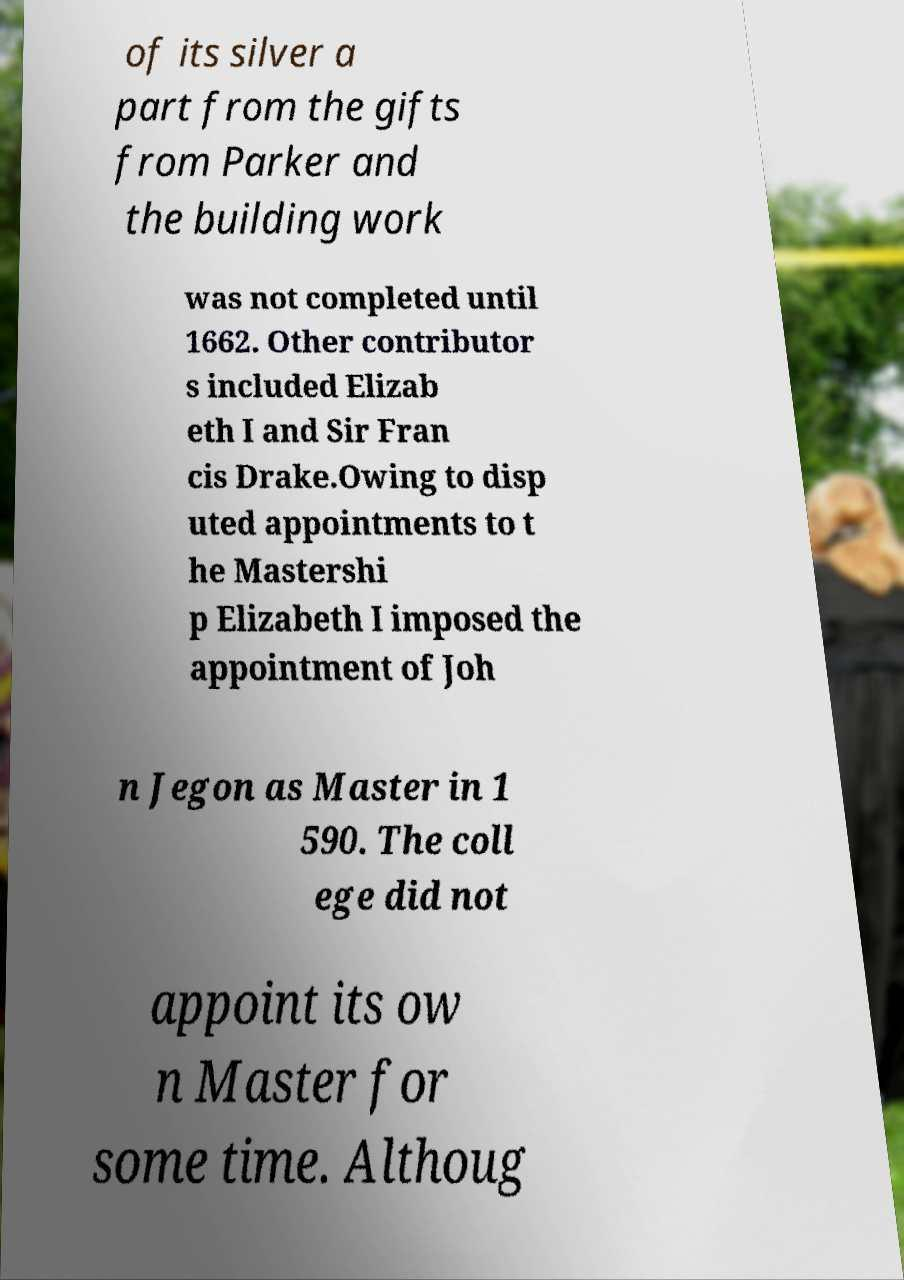Could you extract and type out the text from this image? of its silver a part from the gifts from Parker and the building work was not completed until 1662. Other contributor s included Elizab eth I and Sir Fran cis Drake.Owing to disp uted appointments to t he Mastershi p Elizabeth I imposed the appointment of Joh n Jegon as Master in 1 590. The coll ege did not appoint its ow n Master for some time. Althoug 